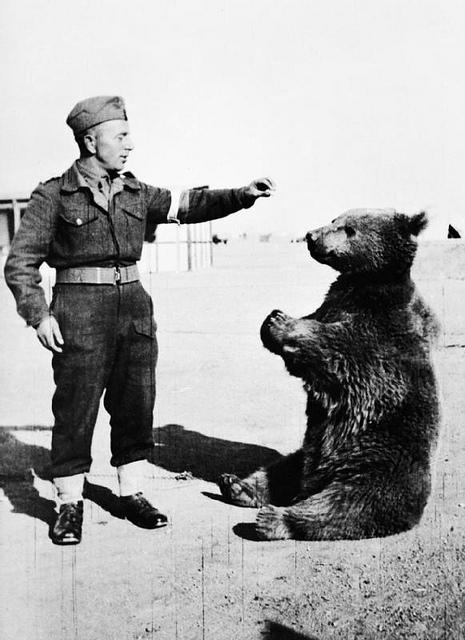Is this a black and white photo?
Be succinct. Yes. What is the man and the bear doing?
Keep it brief. Tricks. Is the man feeding the bear?
Quick response, please. Yes. 